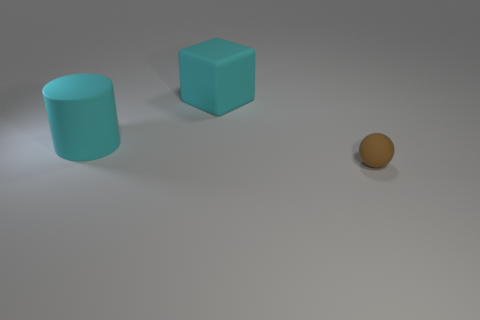Add 3 large cyan cylinders. How many objects exist? 6 Subtract all cylinders. How many objects are left? 2 Subtract 1 cylinders. How many cylinders are left? 0 Subtract all small brown spheres. Subtract all cyan things. How many objects are left? 0 Add 2 large cyan blocks. How many large cyan blocks are left? 3 Add 1 cyan rubber things. How many cyan rubber things exist? 3 Subtract 0 blue cylinders. How many objects are left? 3 Subtract all green cylinders. Subtract all brown balls. How many cylinders are left? 1 